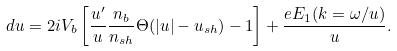Convert formula to latex. <formula><loc_0><loc_0><loc_500><loc_500>d u = 2 i V _ { b } \left [ \frac { u ^ { \prime } } { u } \frac { n _ { b } } { n _ { s h } } \Theta ( | u | - u _ { s h } ) - 1 \right ] + \frac { e E _ { 1 } ( k = \omega / u ) } { u } .</formula> 